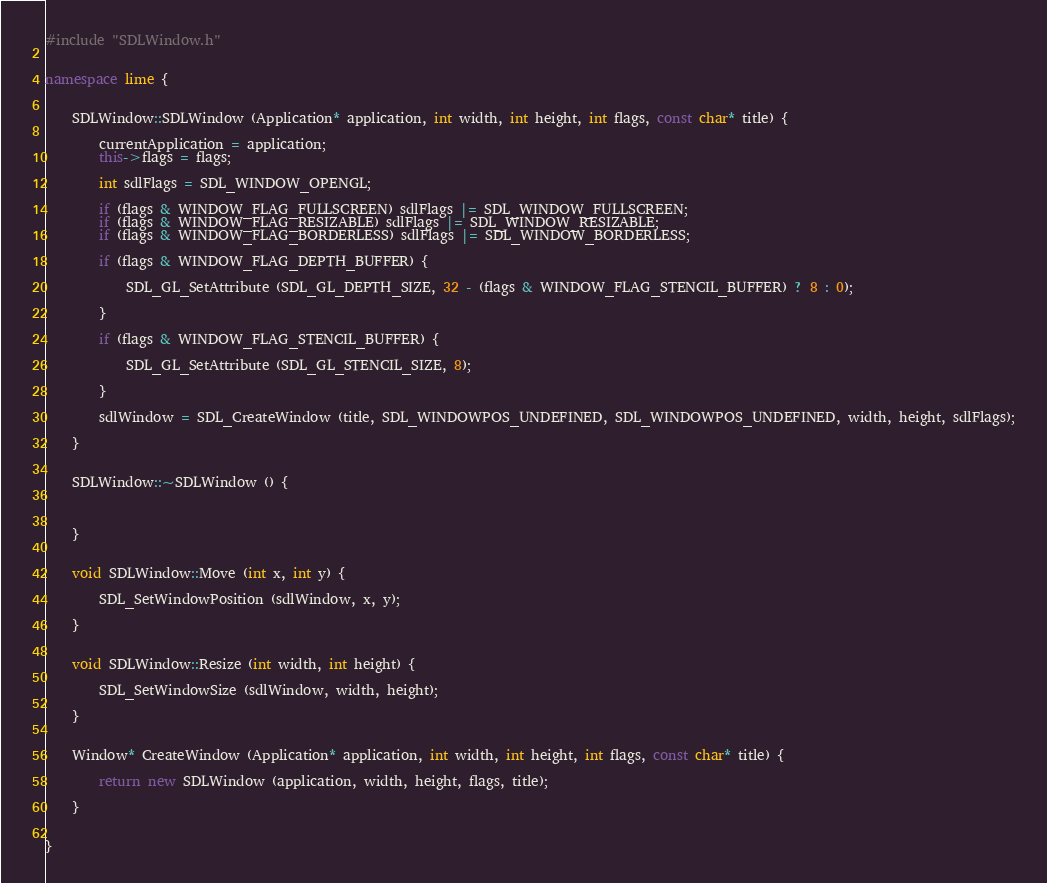Convert code to text. <code><loc_0><loc_0><loc_500><loc_500><_C++_>#include "SDLWindow.h"


namespace lime {
	
	
	SDLWindow::SDLWindow (Application* application, int width, int height, int flags, const char* title) {
		
		currentApplication = application;
		this->flags = flags;
		
		int sdlFlags = SDL_WINDOW_OPENGL;
		
		if (flags & WINDOW_FLAG_FULLSCREEN) sdlFlags |= SDL_WINDOW_FULLSCREEN;
		if (flags & WINDOW_FLAG_RESIZABLE) sdlFlags |= SDL_WINDOW_RESIZABLE;
		if (flags & WINDOW_FLAG_BORDERLESS) sdlFlags |= SDL_WINDOW_BORDERLESS;
		
		if (flags & WINDOW_FLAG_DEPTH_BUFFER) {
			
			SDL_GL_SetAttribute (SDL_GL_DEPTH_SIZE, 32 - (flags & WINDOW_FLAG_STENCIL_BUFFER) ? 8 : 0);
			
		}
		
		if (flags & WINDOW_FLAG_STENCIL_BUFFER) {
			
			SDL_GL_SetAttribute (SDL_GL_STENCIL_SIZE, 8);
			
		}
		
		sdlWindow = SDL_CreateWindow (title, SDL_WINDOWPOS_UNDEFINED, SDL_WINDOWPOS_UNDEFINED, width, height, sdlFlags);
		
	}
	
	
	SDLWindow::~SDLWindow () {
		
		
		
	}
	
	
	void SDLWindow::Move (int x, int y) {
		
		SDL_SetWindowPosition (sdlWindow, x, y);
		
	}
	
	
	void SDLWindow::Resize (int width, int height) {
		
		SDL_SetWindowSize (sdlWindow, width, height);
		
	}
	
	
	Window* CreateWindow (Application* application, int width, int height, int flags, const char* title) {
		
		return new SDLWindow (application, width, height, flags, title);
		
	}
	
	
}</code> 